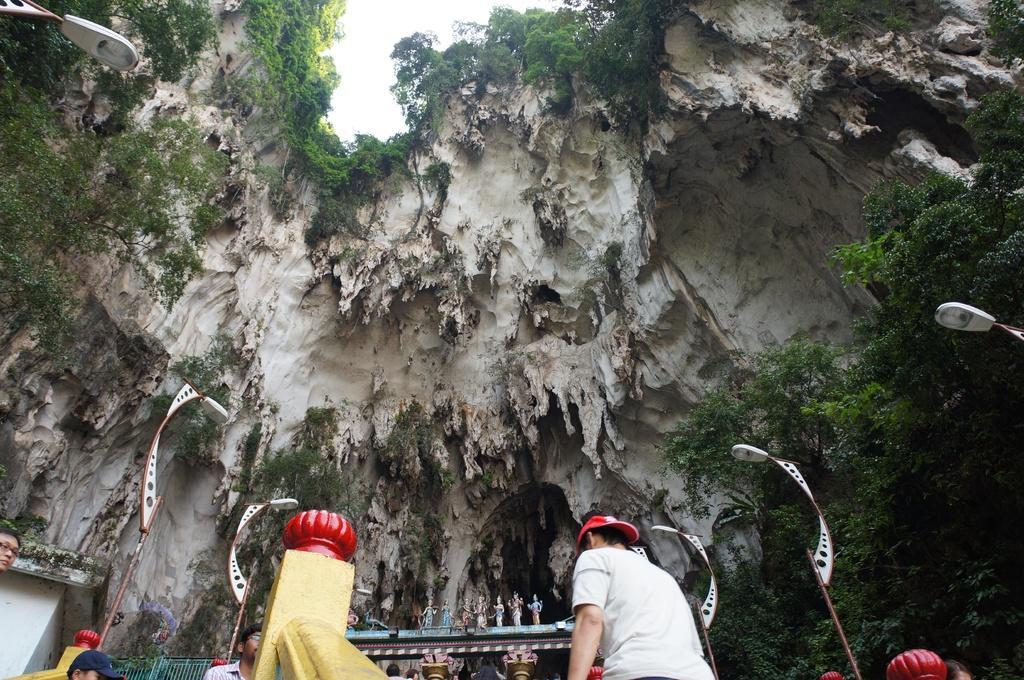How would you summarize this image in a sentence or two? In this picture there are people at the bottom side of the image, it seems to be a cave. 